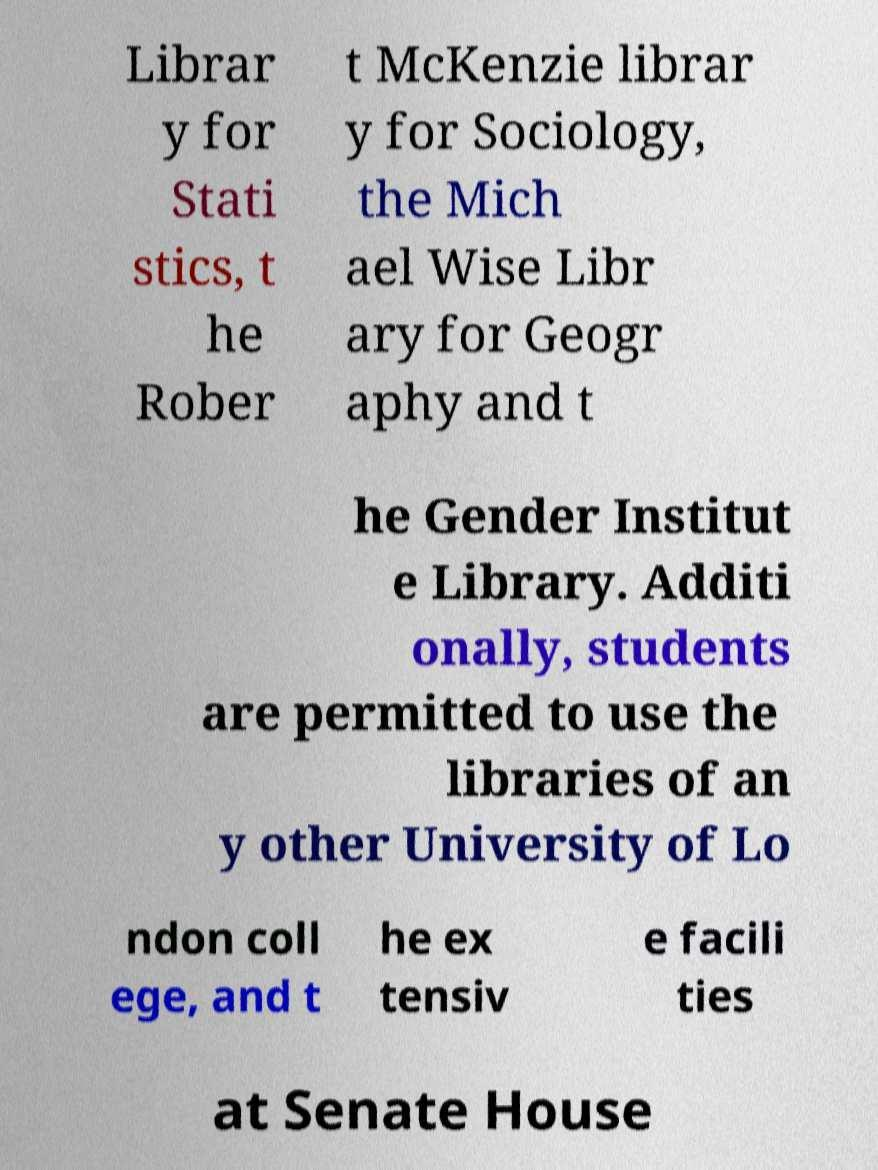What messages or text are displayed in this image? I need them in a readable, typed format. Librar y for Stati stics, t he Rober t McKenzie librar y for Sociology, the Mich ael Wise Libr ary for Geogr aphy and t he Gender Institut e Library. Additi onally, students are permitted to use the libraries of an y other University of Lo ndon coll ege, and t he ex tensiv e facili ties at Senate House 